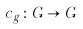Convert formula to latex. <formula><loc_0><loc_0><loc_500><loc_500>c _ { g } \colon G \to G</formula> 